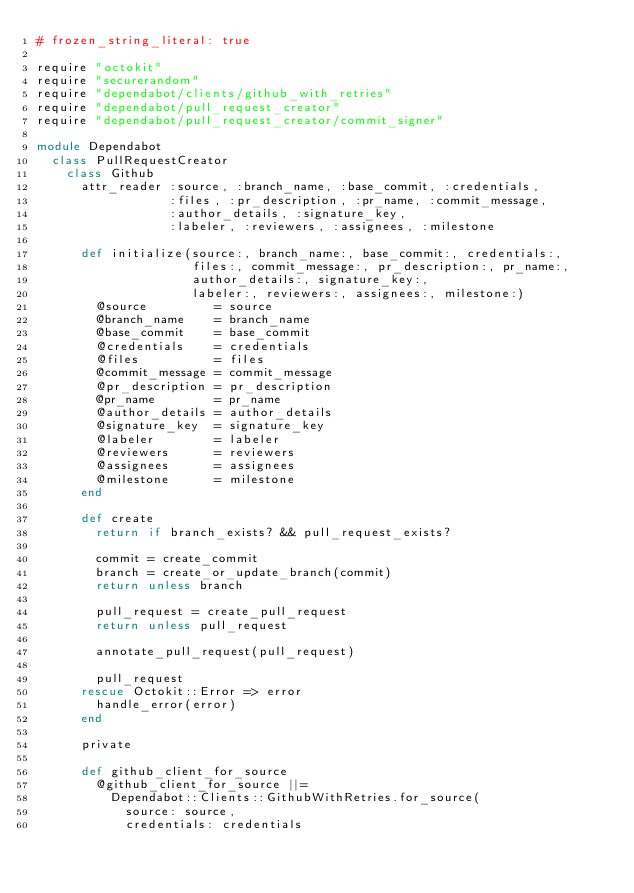<code> <loc_0><loc_0><loc_500><loc_500><_Ruby_># frozen_string_literal: true

require "octokit"
require "securerandom"
require "dependabot/clients/github_with_retries"
require "dependabot/pull_request_creator"
require "dependabot/pull_request_creator/commit_signer"

module Dependabot
  class PullRequestCreator
    class Github
      attr_reader :source, :branch_name, :base_commit, :credentials,
                  :files, :pr_description, :pr_name, :commit_message,
                  :author_details, :signature_key,
                  :labeler, :reviewers, :assignees, :milestone

      def initialize(source:, branch_name:, base_commit:, credentials:,
                     files:, commit_message:, pr_description:, pr_name:,
                     author_details:, signature_key:,
                     labeler:, reviewers:, assignees:, milestone:)
        @source         = source
        @branch_name    = branch_name
        @base_commit    = base_commit
        @credentials    = credentials
        @files          = files
        @commit_message = commit_message
        @pr_description = pr_description
        @pr_name        = pr_name
        @author_details = author_details
        @signature_key  = signature_key
        @labeler        = labeler
        @reviewers      = reviewers
        @assignees      = assignees
        @milestone      = milestone
      end

      def create
        return if branch_exists? && pull_request_exists?

        commit = create_commit
        branch = create_or_update_branch(commit)
        return unless branch

        pull_request = create_pull_request
        return unless pull_request

        annotate_pull_request(pull_request)

        pull_request
      rescue Octokit::Error => error
        handle_error(error)
      end

      private

      def github_client_for_source
        @github_client_for_source ||=
          Dependabot::Clients::GithubWithRetries.for_source(
            source: source,
            credentials: credentials</code> 